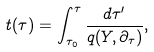Convert formula to latex. <formula><loc_0><loc_0><loc_500><loc_500>t ( \tau ) = \int _ { \tau _ { 0 } } ^ { \tau } \frac { d \tau ^ { \prime } } { q ( Y , \partial _ { \tau } ) } ,</formula> 